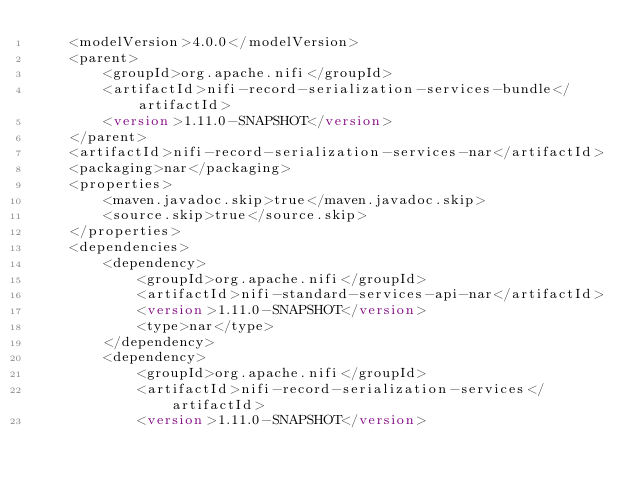Convert code to text. <code><loc_0><loc_0><loc_500><loc_500><_XML_>    <modelVersion>4.0.0</modelVersion>
    <parent>
        <groupId>org.apache.nifi</groupId>
        <artifactId>nifi-record-serialization-services-bundle</artifactId>
        <version>1.11.0-SNAPSHOT</version>
    </parent>
    <artifactId>nifi-record-serialization-services-nar</artifactId>
    <packaging>nar</packaging>
    <properties>
        <maven.javadoc.skip>true</maven.javadoc.skip>
        <source.skip>true</source.skip>
    </properties>
    <dependencies>
        <dependency>
            <groupId>org.apache.nifi</groupId>
            <artifactId>nifi-standard-services-api-nar</artifactId>
            <version>1.11.0-SNAPSHOT</version>
            <type>nar</type>
        </dependency>
        <dependency>
            <groupId>org.apache.nifi</groupId>
            <artifactId>nifi-record-serialization-services</artifactId>
            <version>1.11.0-SNAPSHOT</version></code> 